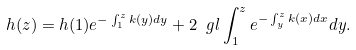Convert formula to latex. <formula><loc_0><loc_0><loc_500><loc_500>h ( z ) = h ( 1 ) e ^ { - \int _ { 1 } ^ { z } k ( y ) d y } + 2 \ g l \int _ { 1 } ^ { z } e ^ { - \int _ { y } ^ { z } k ( x ) d x } d y .</formula> 